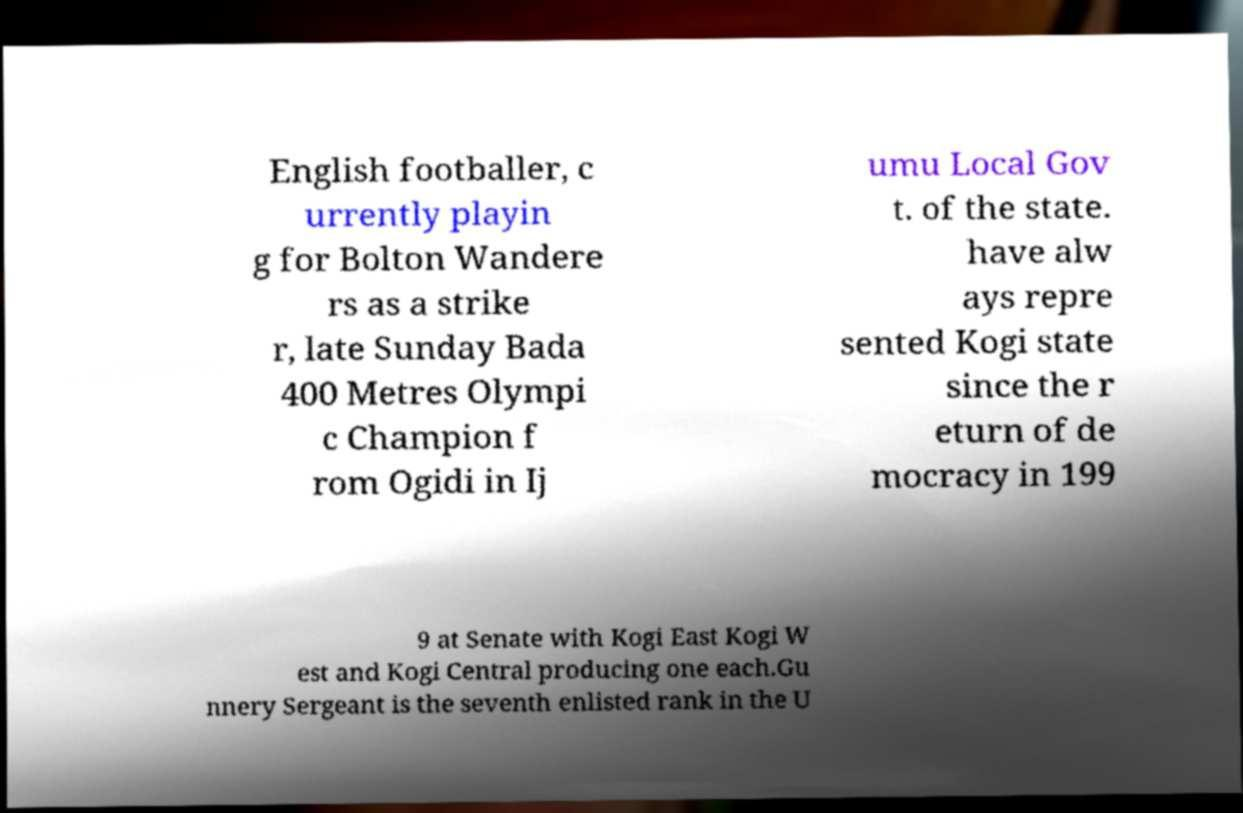Can you read and provide the text displayed in the image?This photo seems to have some interesting text. Can you extract and type it out for me? English footballer, c urrently playin g for Bolton Wandere rs as a strike r, late Sunday Bada 400 Metres Olympi c Champion f rom Ogidi in Ij umu Local Gov t. of the state. have alw ays repre sented Kogi state since the r eturn of de mocracy in 199 9 at Senate with Kogi East Kogi W est and Kogi Central producing one each.Gu nnery Sergeant is the seventh enlisted rank in the U 